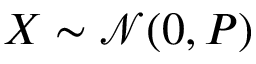Convert formula to latex. <formula><loc_0><loc_0><loc_500><loc_500>X \sim { \mathcal { N } } ( 0 , P ) \,</formula> 